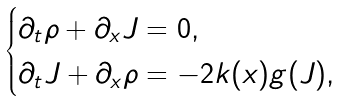Convert formula to latex. <formula><loc_0><loc_0><loc_500><loc_500>\begin{cases} \partial _ { t } \rho + \partial _ { x } J = 0 , & \\ \partial _ { t } J + \partial _ { x } \rho = - 2 k ( x ) g ( J ) , & \end{cases}</formula> 